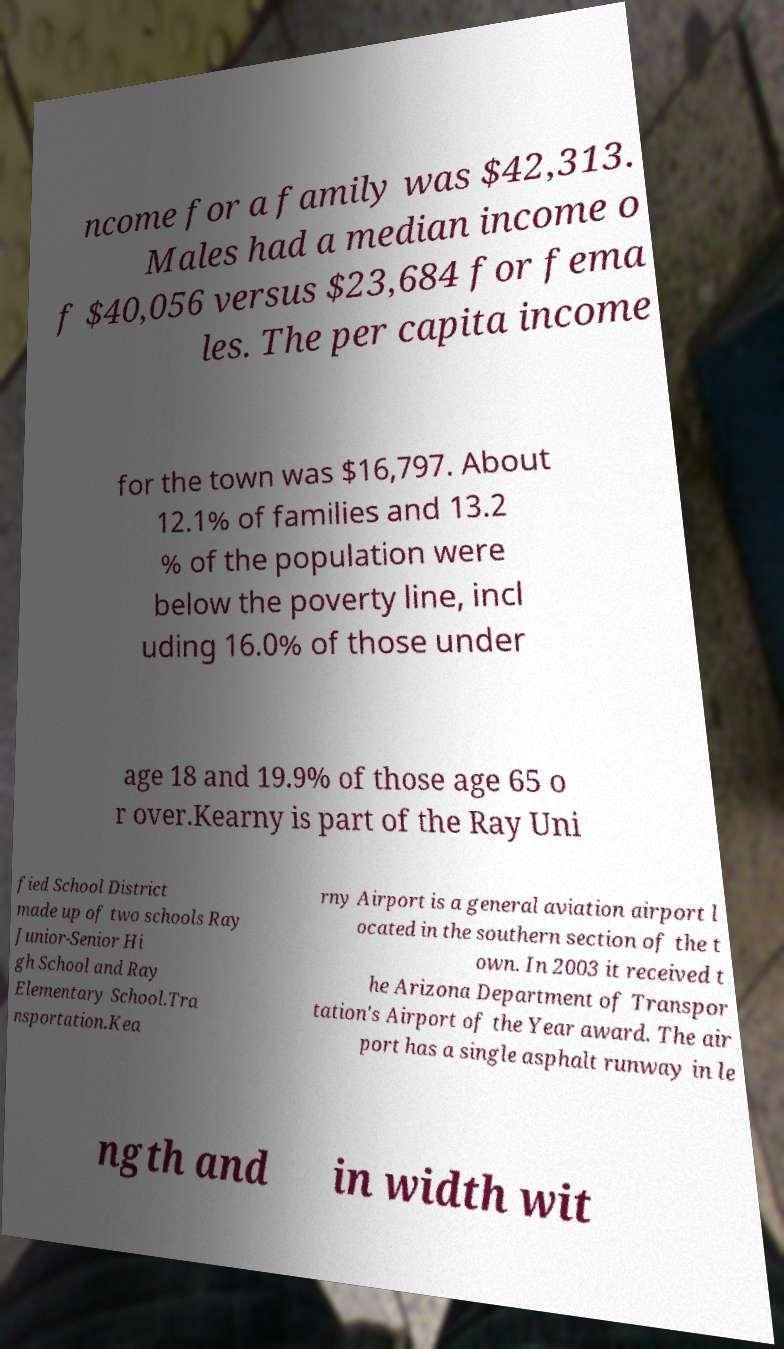Can you accurately transcribe the text from the provided image for me? ncome for a family was $42,313. Males had a median income o f $40,056 versus $23,684 for fema les. The per capita income for the town was $16,797. About 12.1% of families and 13.2 % of the population were below the poverty line, incl uding 16.0% of those under age 18 and 19.9% of those age 65 o r over.Kearny is part of the Ray Uni fied School District made up of two schools Ray Junior-Senior Hi gh School and Ray Elementary School.Tra nsportation.Kea rny Airport is a general aviation airport l ocated in the southern section of the t own. In 2003 it received t he Arizona Department of Transpor tation's Airport of the Year award. The air port has a single asphalt runway in le ngth and in width wit 